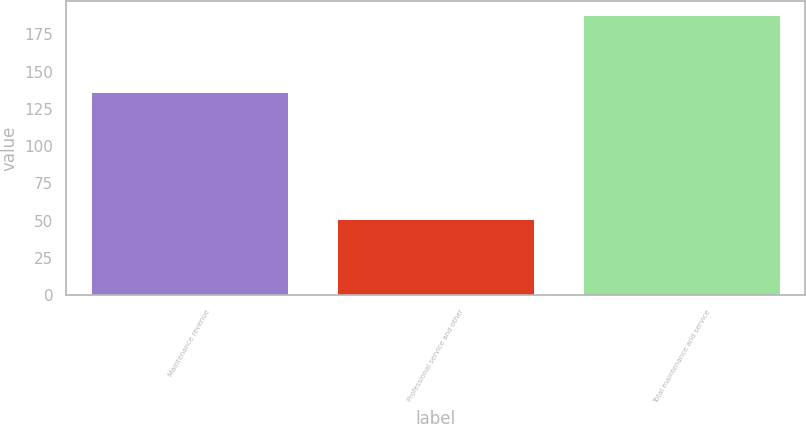<chart> <loc_0><loc_0><loc_500><loc_500><bar_chart><fcel>Maintenance revenue<fcel>Professional service and other<fcel>Total maintenance and service<nl><fcel>136.3<fcel>51.4<fcel>187.7<nl></chart> 